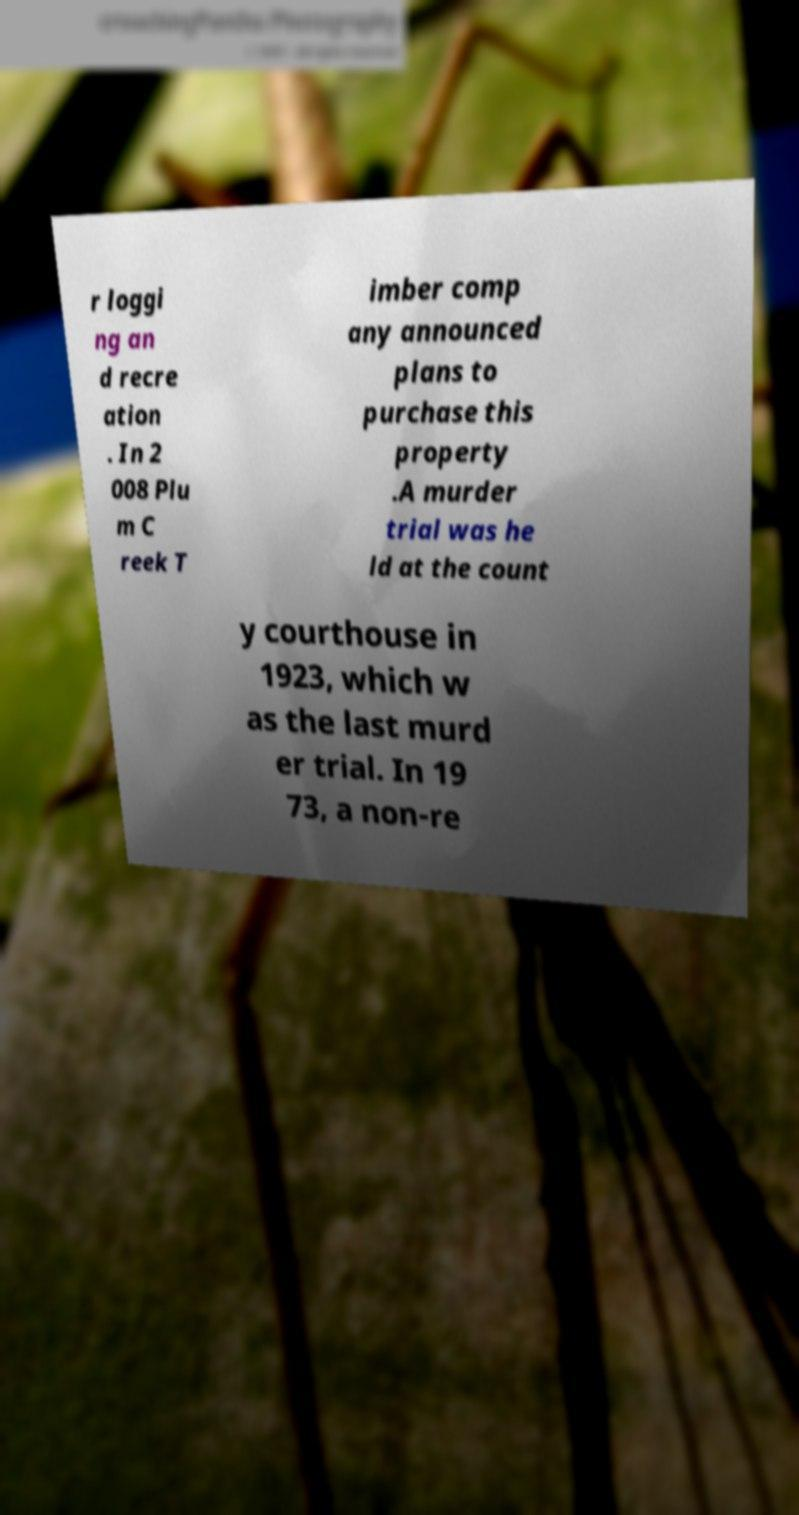For documentation purposes, I need the text within this image transcribed. Could you provide that? r loggi ng an d recre ation . In 2 008 Plu m C reek T imber comp any announced plans to purchase this property .A murder trial was he ld at the count y courthouse in 1923, which w as the last murd er trial. In 19 73, a non-re 